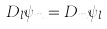Convert formula to latex. <formula><loc_0><loc_0><loc_500><loc_500>D _ { l } \psi _ { m } = D _ { m } \psi _ { l }</formula> 